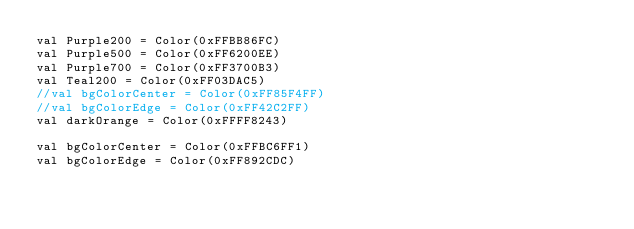Convert code to text. <code><loc_0><loc_0><loc_500><loc_500><_Kotlin_>val Purple200 = Color(0xFFBB86FC)
val Purple500 = Color(0xFF6200EE)
val Purple700 = Color(0xFF3700B3)
val Teal200 = Color(0xFF03DAC5)
//val bgColorCenter = Color(0xFF85F4FF)
//val bgColorEdge = Color(0xFF42C2FF)
val darkOrange = Color(0xFFFF8243)

val bgColorCenter = Color(0xFFBC6FF1)
val bgColorEdge = Color(0xFF892CDC)</code> 